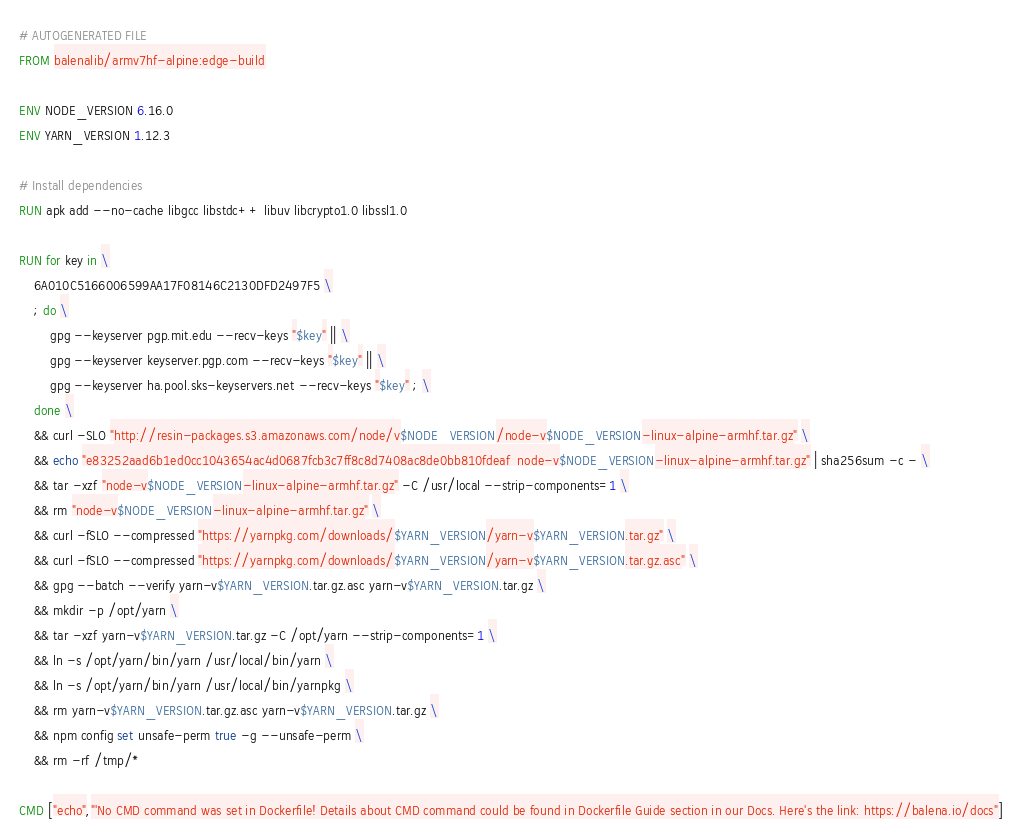<code> <loc_0><loc_0><loc_500><loc_500><_Dockerfile_># AUTOGENERATED FILE
FROM balenalib/armv7hf-alpine:edge-build

ENV NODE_VERSION 6.16.0
ENV YARN_VERSION 1.12.3

# Install dependencies
RUN apk add --no-cache libgcc libstdc++ libuv libcrypto1.0 libssl1.0

RUN for key in \
	6A010C5166006599AA17F08146C2130DFD2497F5 \
	; do \
		gpg --keyserver pgp.mit.edu --recv-keys "$key" || \
		gpg --keyserver keyserver.pgp.com --recv-keys "$key" || \
		gpg --keyserver ha.pool.sks-keyservers.net --recv-keys "$key" ; \
	done \
	&& curl -SLO "http://resin-packages.s3.amazonaws.com/node/v$NODE_VERSION/node-v$NODE_VERSION-linux-alpine-armhf.tar.gz" \
	&& echo "e83252aad6b1ed0cc1043654ac4d0687fcb3c7ff8c8d7408ac8de0bb810fdeaf  node-v$NODE_VERSION-linux-alpine-armhf.tar.gz" | sha256sum -c - \
	&& tar -xzf "node-v$NODE_VERSION-linux-alpine-armhf.tar.gz" -C /usr/local --strip-components=1 \
	&& rm "node-v$NODE_VERSION-linux-alpine-armhf.tar.gz" \
	&& curl -fSLO --compressed "https://yarnpkg.com/downloads/$YARN_VERSION/yarn-v$YARN_VERSION.tar.gz" \
	&& curl -fSLO --compressed "https://yarnpkg.com/downloads/$YARN_VERSION/yarn-v$YARN_VERSION.tar.gz.asc" \
	&& gpg --batch --verify yarn-v$YARN_VERSION.tar.gz.asc yarn-v$YARN_VERSION.tar.gz \
	&& mkdir -p /opt/yarn \
	&& tar -xzf yarn-v$YARN_VERSION.tar.gz -C /opt/yarn --strip-components=1 \
	&& ln -s /opt/yarn/bin/yarn /usr/local/bin/yarn \
	&& ln -s /opt/yarn/bin/yarn /usr/local/bin/yarnpkg \
	&& rm yarn-v$YARN_VERSION.tar.gz.asc yarn-v$YARN_VERSION.tar.gz \
	&& npm config set unsafe-perm true -g --unsafe-perm \
	&& rm -rf /tmp/*

CMD ["echo","'No CMD command was set in Dockerfile! Details about CMD command could be found in Dockerfile Guide section in our Docs. Here's the link: https://balena.io/docs"]</code> 